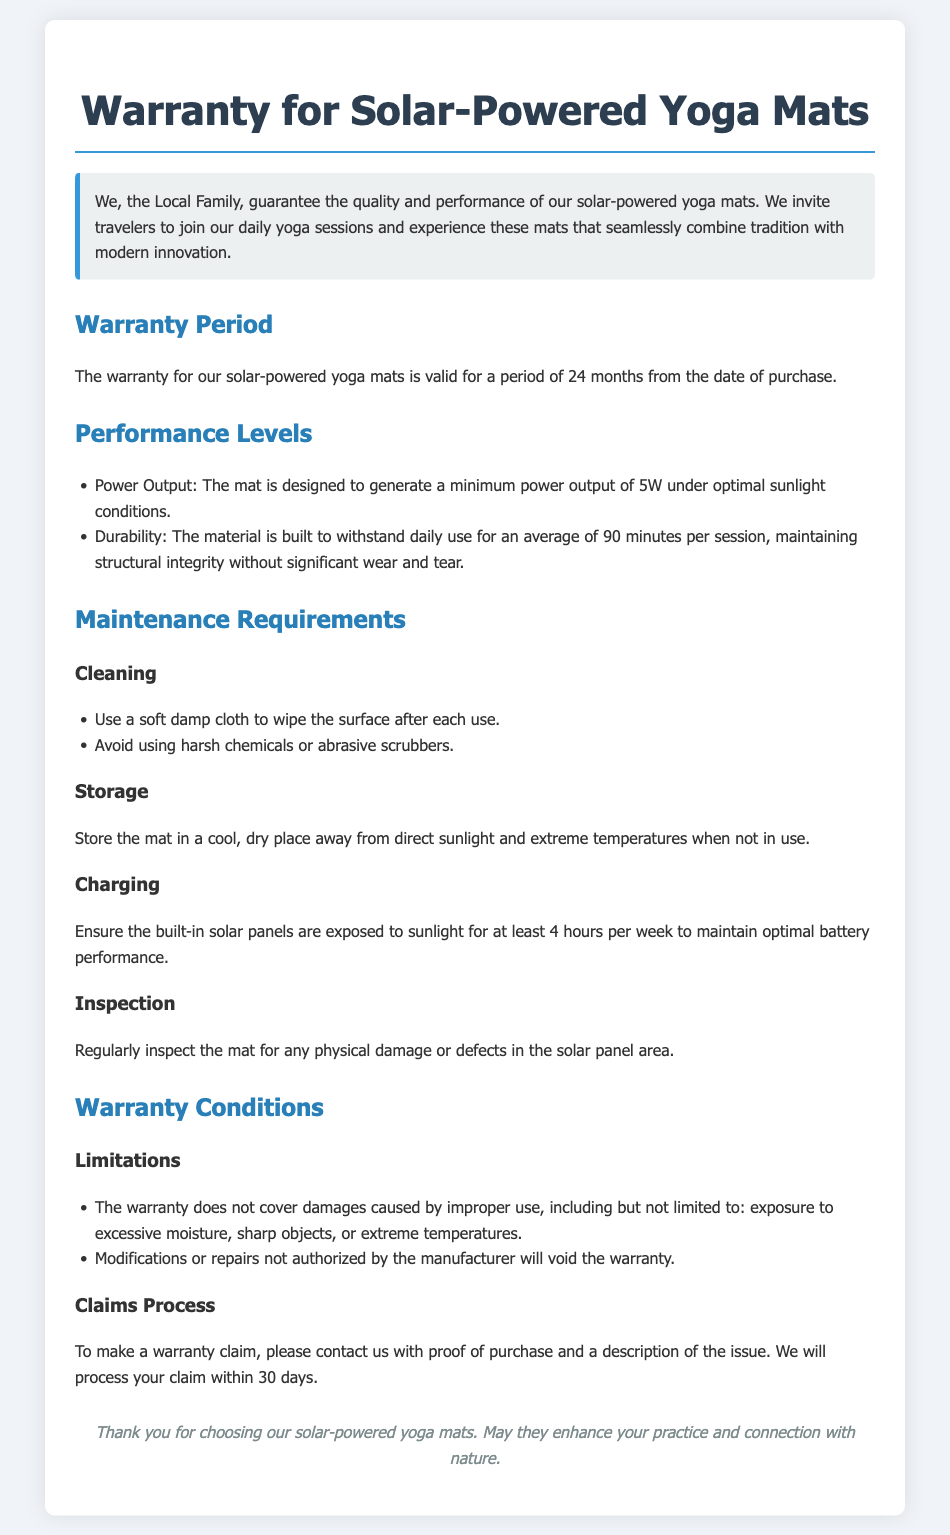What is the warranty period for the yoga mat? The warranty period is specified in the document as valid for a period of 24 months from the date of purchase.
Answer: 24 months What is the minimum power output of the yoga mat? The document mentions that the mat is designed to generate a minimum power output under optimal sunlight conditions.
Answer: 5W What should be used to clean the solar-powered yoga mat? The document explains that a soft damp cloth should be used for cleaning the mat's surface.
Answer: Soft damp cloth How many hours of sunlight exposure are required weekly for optimal battery performance? The warranty document states the requirement to maintain optimal battery performance is exposure to sunlight for a specific duration per week.
Answer: 4 hours What conditions will void the warranty? The document lists certain actions or circumstances that will lead to the warranty being voided, including unauthorized modifications.
Answer: Improper use What is the claims process for warranty issues? The document describes the necessary steps to take when making a warranty claim, including contacting the seller with specific information.
Answer: Proof of purchase How should the mat be stored when not in use? The storage instructions in the document specify conditions under which the yoga mat should be stored when not being used.
Answer: Cool, dry place What is the durability expectation for the mat? The warranty document provides information regarding the product's durability while being used in daily sessions.
Answer: Daily use for an average of 90 minutes What kind of damages are not covered under the warranty? The warranty specifies limitations on the coverage, including damages caused by specific improper uses.
Answer: Excessive moisture 